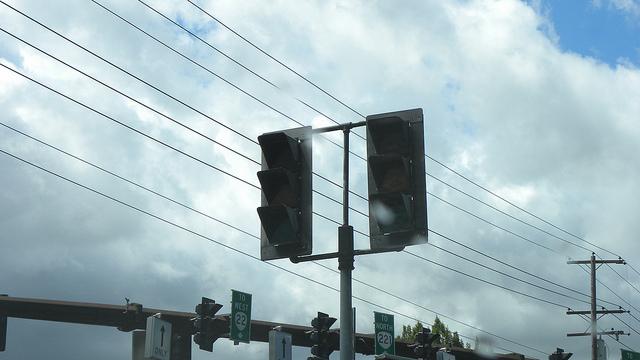How many signs are in the picture?
Write a very short answer. 4. Are the lights working?
Concise answer only. No. Is it a blizzard out?
Be succinct. No. Is this in a city?
Be succinct. Yes. How many clouds are in the sky?
Short answer required. Many. 